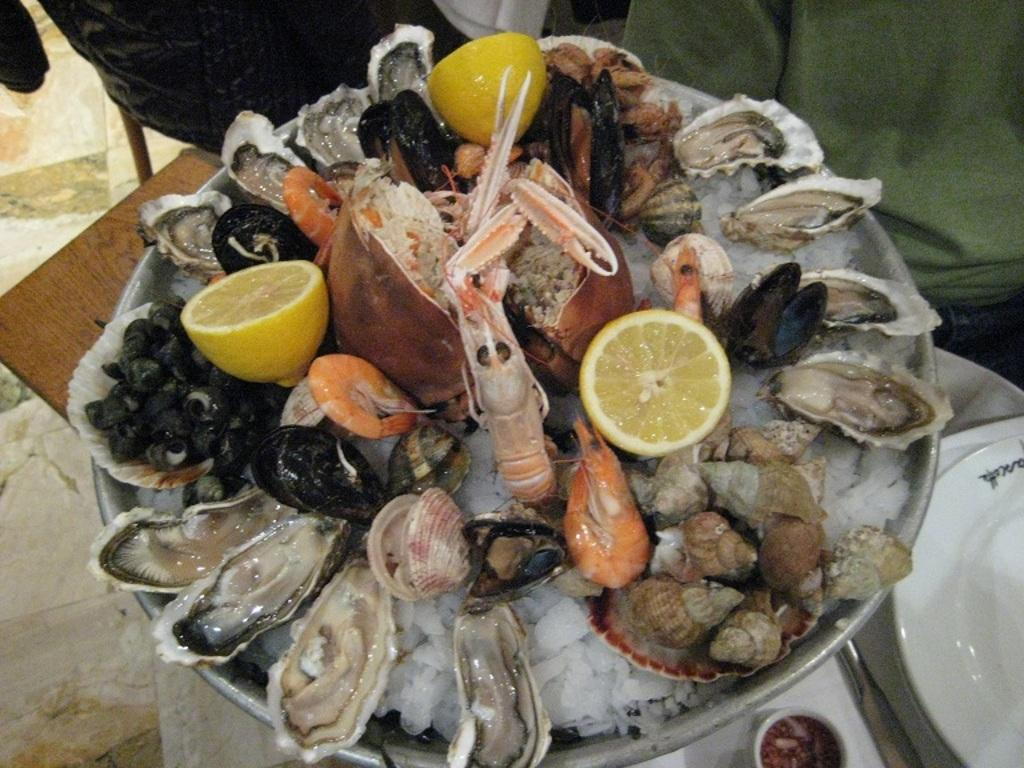What type of food can be seen in the image? There is seafood in the image. What other items are present in the image? There are lemons in the image. How are the seafood and lemons arranged in the image? The seafood and lemons are in a bowl. What type of condition is the spade in, as seen in the image? There is no spade present in the image. What riddle can be solved using the information in the image? The image does not contain any riddles or puzzles to be solved. 